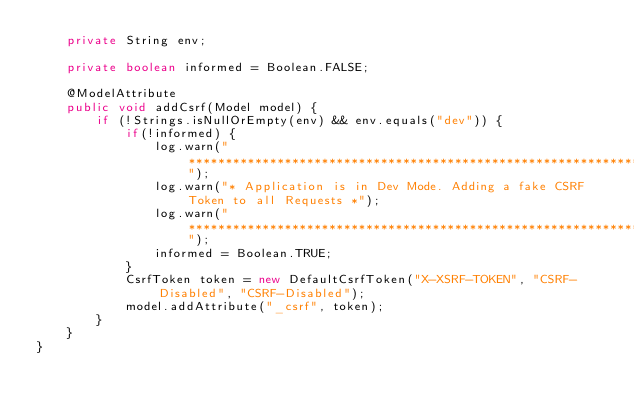Convert code to text. <code><loc_0><loc_0><loc_500><loc_500><_Java_>	private String env;

	private boolean informed = Boolean.FALSE;

	@ModelAttribute
    public void addCsrf(Model model) {
		if (!Strings.isNullOrEmpty(env) && env.equals("dev")) {
			if(!informed) {
				log.warn("************************************************************************");
				log.warn("* Application is in Dev Mode. Adding a fake CSRF Token to all Requests *");
				log.warn("************************************************************************");
				informed = Boolean.TRUE;
			}
			CsrfToken token = new DefaultCsrfToken("X-XSRF-TOKEN", "CSRF-Disabled", "CSRF-Disabled");
			model.addAttribute("_csrf", token);
		}
    }
}</code> 